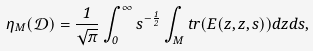Convert formula to latex. <formula><loc_0><loc_0><loc_500><loc_500>\eta _ { M } ( \mathcal { D } ) = \frac { 1 } { \sqrt { \pi } } \int _ { 0 } ^ { \infty } s ^ { - \frac { 1 } { 2 } } \int _ { M } t r ( E ( z , z , s ) ) d z d s ,</formula> 